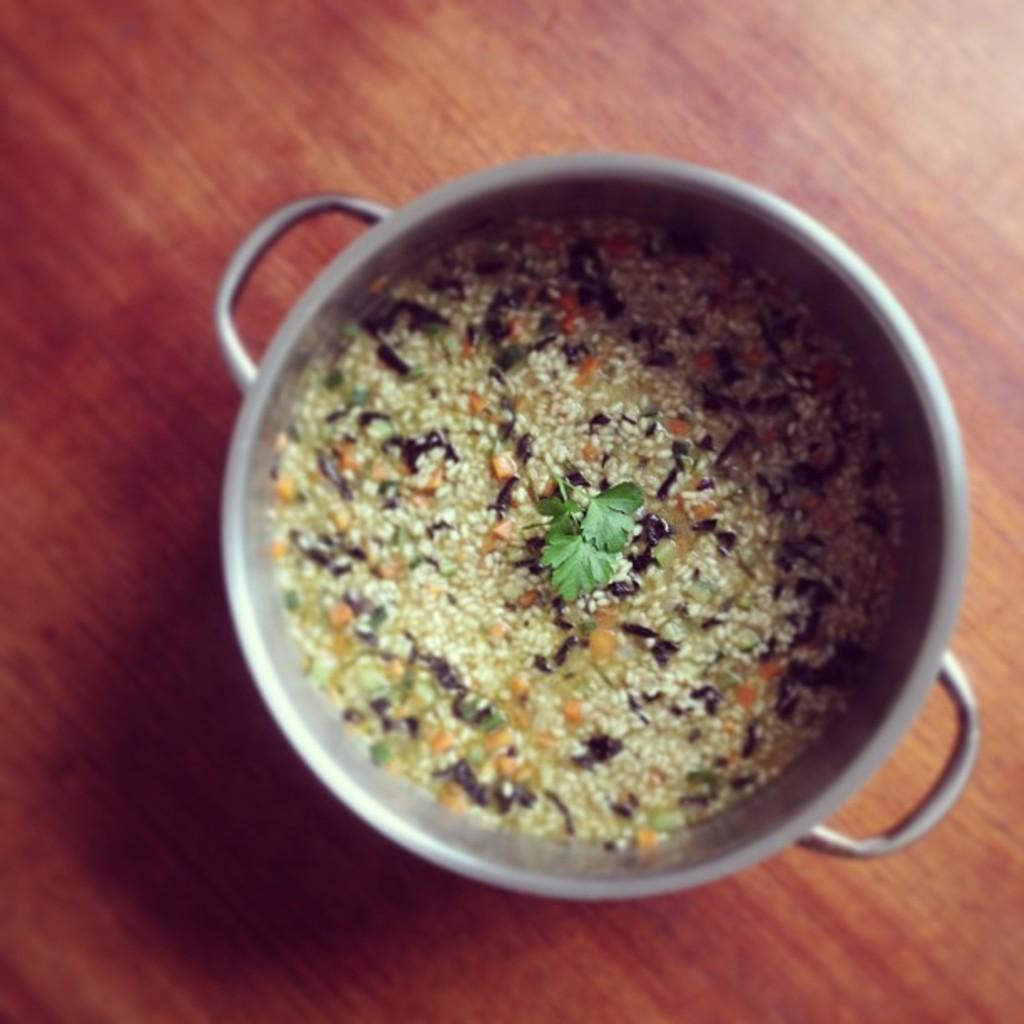What is the main subject in the image? There is an edible in the image. How is the edible contained or held in the image? The edible is placed in a vessel. Where is the vessel with the edible located? The vessel with the edible is on a table. What type of cushion is placed on top of the edible in the image? There is no cushion present in the image. Can you tell me how much zinc is contained within the edible in the image? There is no information about the zinc content of the edible in the image. 